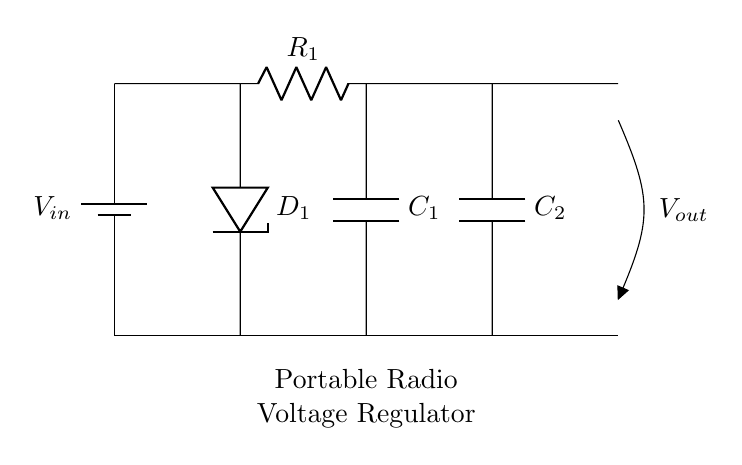What is the input component of the circuit? The circuit has a battery as the input component, denoted as V_in. It is located on the left side of the circuit.
Answer: battery What is the function of the Zener diode in this circuit? The Zener diode serves to stabilize the output voltage by allowing current to flow in reverse when a specific voltage threshold is exceeded, hence maintaining a constant output voltage.
Answer: voltage stabilization How many capacitors are present in the circuit? There are two capacitors in the circuit, labeled as C_1 and C_2, located near the output section, each positioned below one another.
Answer: two What is the voltage represented at the output terminal? The output terminal is labeled V_out, showing that it outputs regulated voltage to the connected load. The output is located on the right side of the circuit.
Answer: V_out What is the role of the resistor in this circuit? The resistor, labeled R_1, is used to limit the current flowing through the Zener diode, which protects it from excessive current to function correctly in regulating the output voltage.
Answer: current limiting How is the ground connected in the circuit? The ground connection is established through a short that links the negative terminal of the battery at the bottom to the output, ensuring all components share a common reference point for voltage.
Answer: common ground What component is used for filtering in this regulator circuit? The capacitors C_1 and C_2 are primarily used for filtering; they smooth out any fluctuations in the output voltage to provide a stable DC output to the radio.
Answer: capacitors 